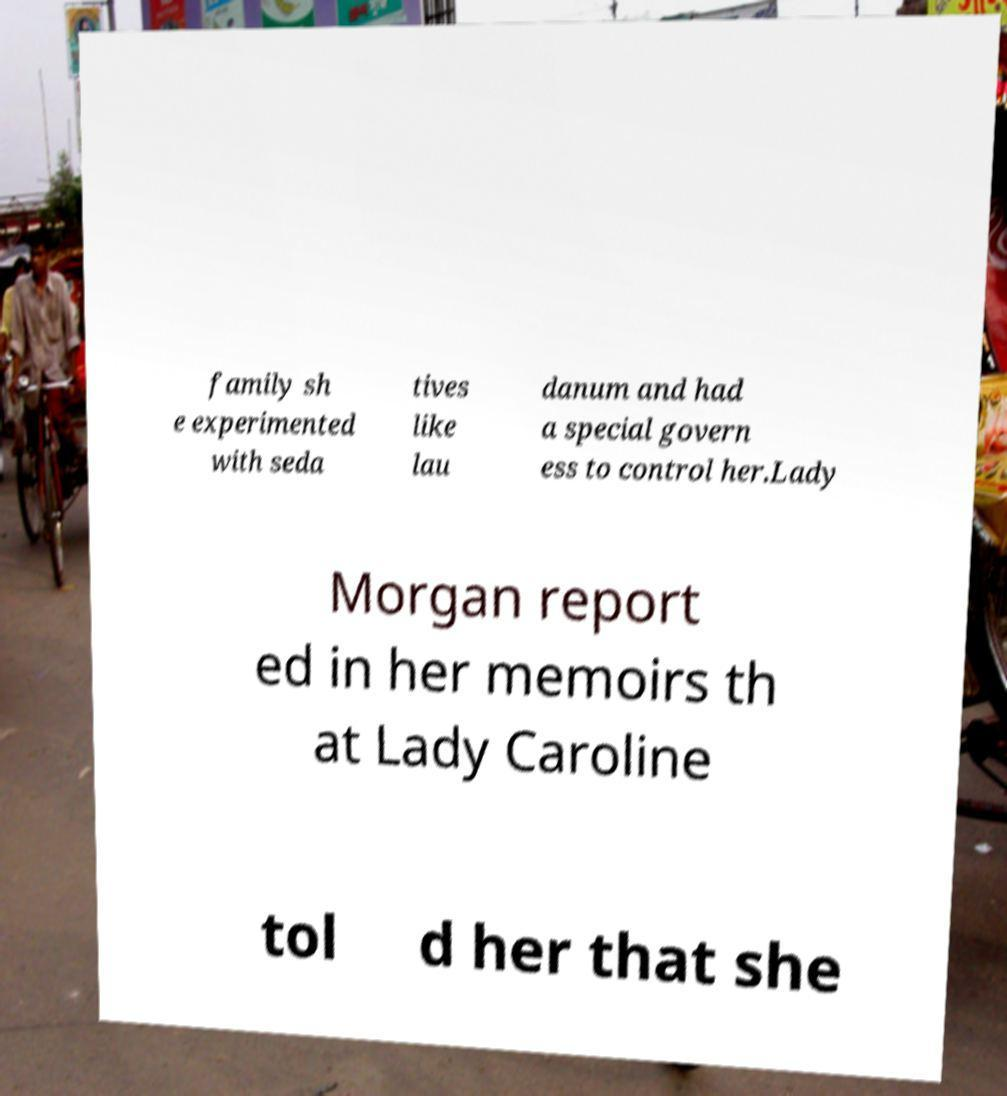Can you accurately transcribe the text from the provided image for me? family sh e experimented with seda tives like lau danum and had a special govern ess to control her.Lady Morgan report ed in her memoirs th at Lady Caroline tol d her that she 